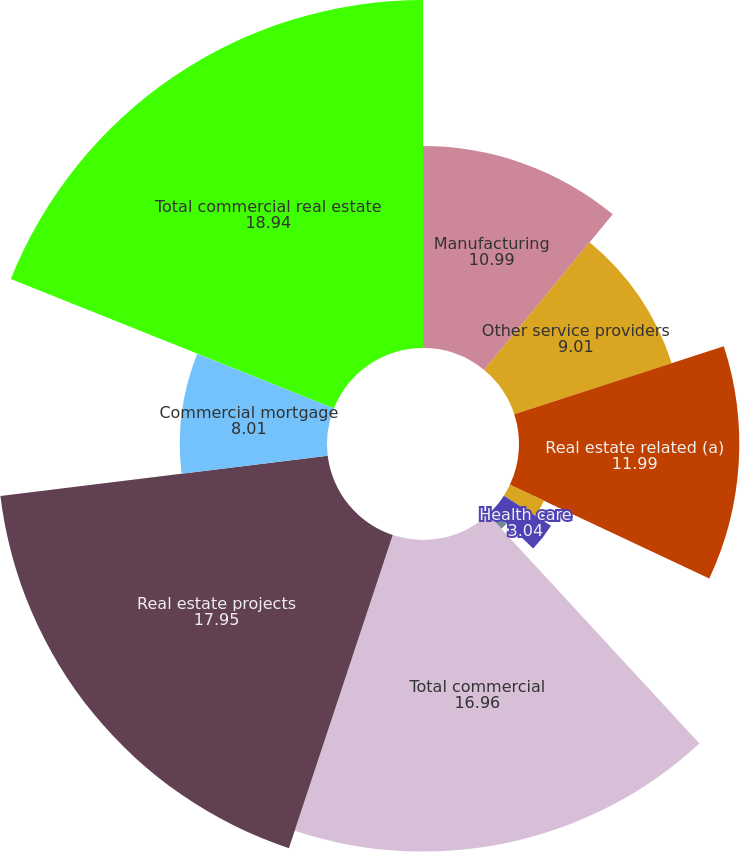Convert chart. <chart><loc_0><loc_0><loc_500><loc_500><pie_chart><fcel>Manufacturing<fcel>Other service providers<fcel>Real estate related (a)<fcel>Financial services<fcel>Health care<fcel>Other<fcel>Total commercial<fcel>Real estate projects<fcel>Commercial mortgage<fcel>Total commercial real estate<nl><fcel>10.99%<fcel>9.01%<fcel>11.99%<fcel>2.05%<fcel>3.04%<fcel>1.06%<fcel>16.96%<fcel>17.95%<fcel>8.01%<fcel>18.94%<nl></chart> 